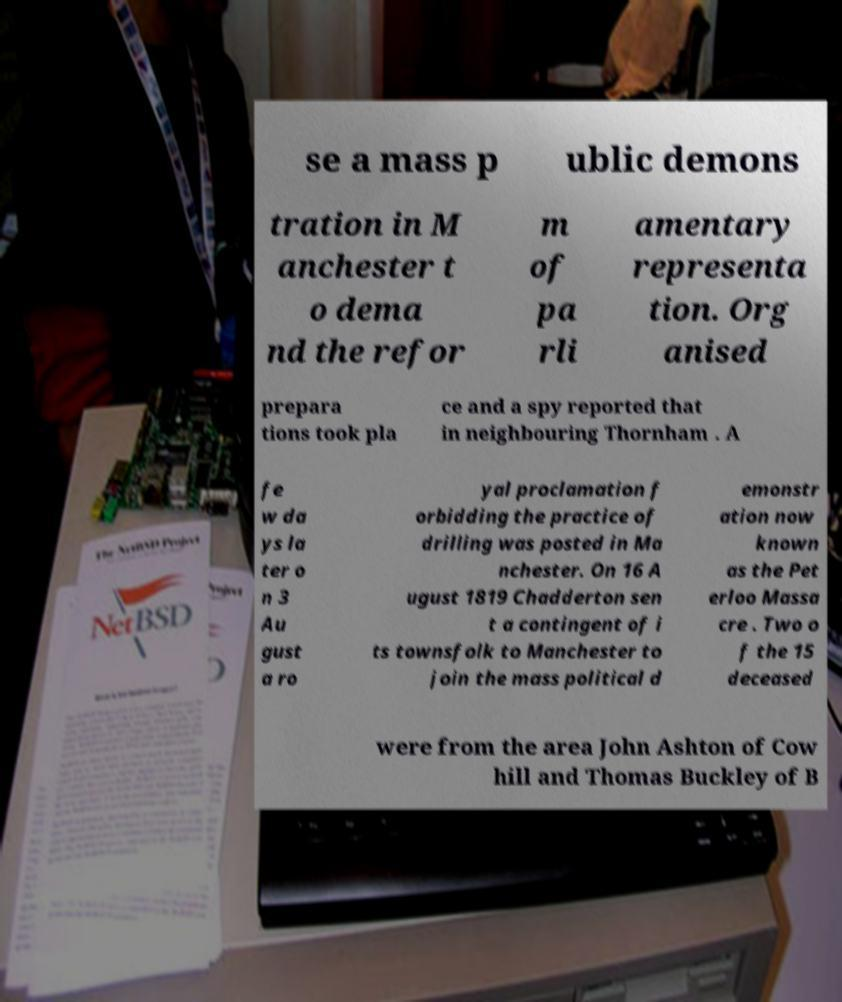I need the written content from this picture converted into text. Can you do that? se a mass p ublic demons tration in M anchester t o dema nd the refor m of pa rli amentary representa tion. Org anised prepara tions took pla ce and a spy reported that in neighbouring Thornham . A fe w da ys la ter o n 3 Au gust a ro yal proclamation f orbidding the practice of drilling was posted in Ma nchester. On 16 A ugust 1819 Chadderton sen t a contingent of i ts townsfolk to Manchester to join the mass political d emonstr ation now known as the Pet erloo Massa cre . Two o f the 15 deceased were from the area John Ashton of Cow hill and Thomas Buckley of B 